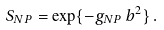<formula> <loc_0><loc_0><loc_500><loc_500>S _ { N P } = \exp \{ - g _ { N P } \, b ^ { 2 } \} \, .</formula> 